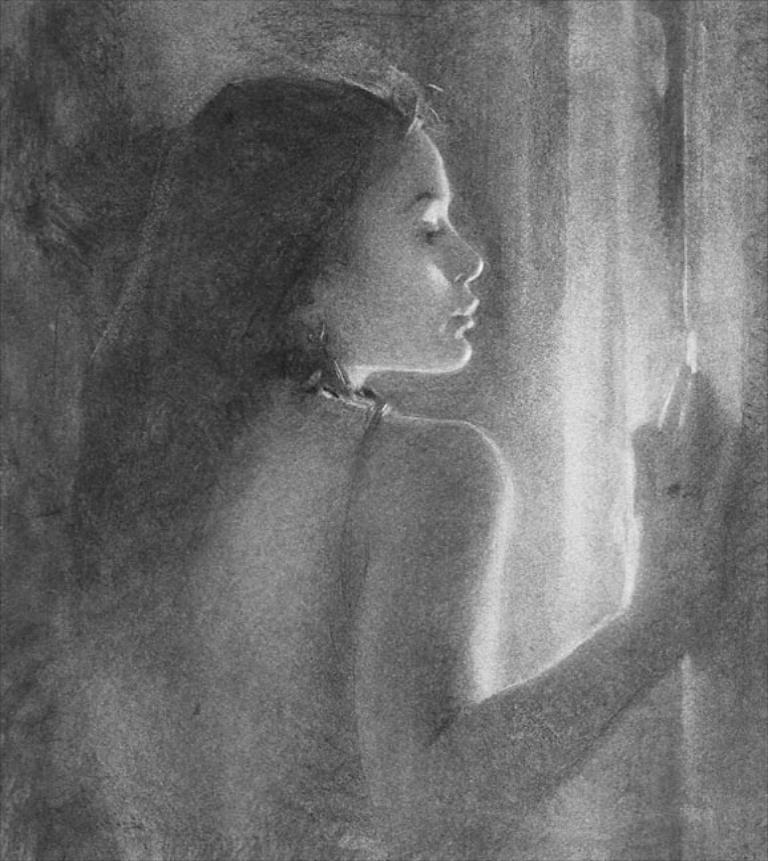In one or two sentences, can you explain what this image depicts? This is black and white image where we can see a woman. 